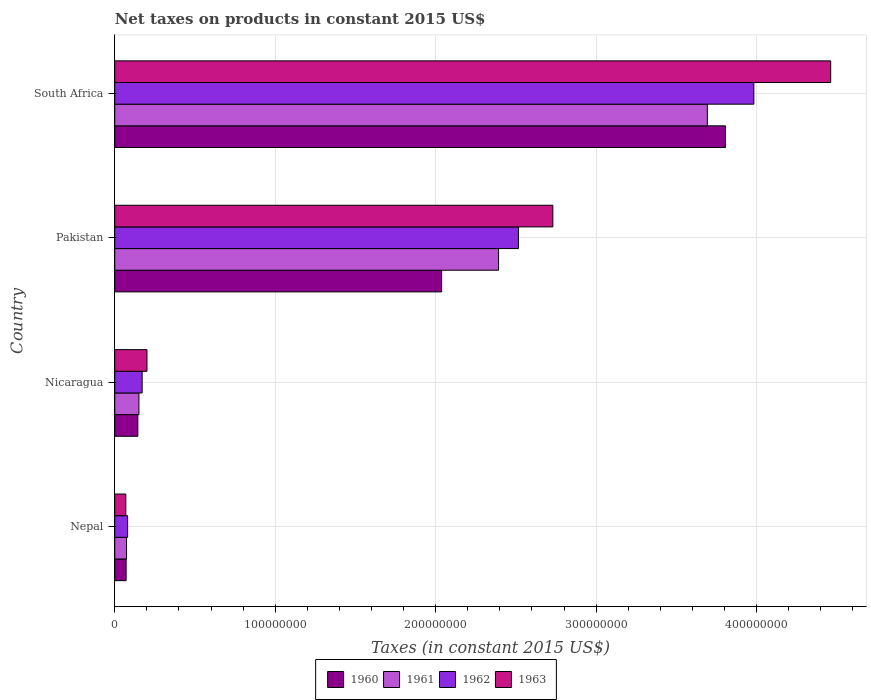How many groups of bars are there?
Offer a very short reply. 4. Are the number of bars per tick equal to the number of legend labels?
Provide a short and direct response. Yes. Are the number of bars on each tick of the Y-axis equal?
Your response must be concise. Yes. What is the label of the 4th group of bars from the top?
Your response must be concise. Nepal. In how many cases, is the number of bars for a given country not equal to the number of legend labels?
Your response must be concise. 0. What is the net taxes on products in 1963 in South Africa?
Provide a succinct answer. 4.46e+08. Across all countries, what is the maximum net taxes on products in 1961?
Ensure brevity in your answer.  3.69e+08. Across all countries, what is the minimum net taxes on products in 1963?
Make the answer very short. 6.89e+06. In which country was the net taxes on products in 1962 maximum?
Your answer should be compact. South Africa. In which country was the net taxes on products in 1961 minimum?
Offer a very short reply. Nepal. What is the total net taxes on products in 1963 in the graph?
Give a very brief answer. 7.46e+08. What is the difference between the net taxes on products in 1962 in Nepal and that in South Africa?
Provide a short and direct response. -3.90e+08. What is the difference between the net taxes on products in 1961 in Nicaragua and the net taxes on products in 1963 in Nepal?
Ensure brevity in your answer.  8.17e+06. What is the average net taxes on products in 1962 per country?
Ensure brevity in your answer.  1.69e+08. What is the difference between the net taxes on products in 1960 and net taxes on products in 1962 in Pakistan?
Give a very brief answer. -4.79e+07. In how many countries, is the net taxes on products in 1963 greater than 200000000 US$?
Offer a very short reply. 2. What is the ratio of the net taxes on products in 1961 in Nicaragua to that in Pakistan?
Ensure brevity in your answer.  0.06. What is the difference between the highest and the second highest net taxes on products in 1961?
Provide a short and direct response. 1.30e+08. What is the difference between the highest and the lowest net taxes on products in 1961?
Your answer should be compact. 3.62e+08. In how many countries, is the net taxes on products in 1960 greater than the average net taxes on products in 1960 taken over all countries?
Provide a succinct answer. 2. What does the 3rd bar from the bottom in Nicaragua represents?
Provide a short and direct response. 1962. Is it the case that in every country, the sum of the net taxes on products in 1963 and net taxes on products in 1962 is greater than the net taxes on products in 1960?
Make the answer very short. Yes. How many bars are there?
Provide a short and direct response. 16. Are all the bars in the graph horizontal?
Provide a short and direct response. Yes. Are the values on the major ticks of X-axis written in scientific E-notation?
Ensure brevity in your answer.  No. Does the graph contain grids?
Offer a very short reply. Yes. Where does the legend appear in the graph?
Your response must be concise. Bottom center. How many legend labels are there?
Give a very brief answer. 4. What is the title of the graph?
Provide a short and direct response. Net taxes on products in constant 2015 US$. Does "1999" appear as one of the legend labels in the graph?
Provide a short and direct response. No. What is the label or title of the X-axis?
Offer a terse response. Taxes (in constant 2015 US$). What is the Taxes (in constant 2015 US$) in 1960 in Nepal?
Your answer should be very brief. 7.09e+06. What is the Taxes (in constant 2015 US$) of 1961 in Nepal?
Ensure brevity in your answer.  7.35e+06. What is the Taxes (in constant 2015 US$) of 1962 in Nepal?
Keep it short and to the point. 8.01e+06. What is the Taxes (in constant 2015 US$) in 1963 in Nepal?
Provide a short and direct response. 6.89e+06. What is the Taxes (in constant 2015 US$) of 1960 in Nicaragua?
Keep it short and to the point. 1.44e+07. What is the Taxes (in constant 2015 US$) of 1961 in Nicaragua?
Give a very brief answer. 1.51e+07. What is the Taxes (in constant 2015 US$) of 1962 in Nicaragua?
Keep it short and to the point. 1.71e+07. What is the Taxes (in constant 2015 US$) of 1963 in Nicaragua?
Offer a terse response. 2.01e+07. What is the Taxes (in constant 2015 US$) of 1960 in Pakistan?
Provide a succinct answer. 2.04e+08. What is the Taxes (in constant 2015 US$) of 1961 in Pakistan?
Ensure brevity in your answer.  2.39e+08. What is the Taxes (in constant 2015 US$) in 1962 in Pakistan?
Your answer should be compact. 2.52e+08. What is the Taxes (in constant 2015 US$) of 1963 in Pakistan?
Keep it short and to the point. 2.73e+08. What is the Taxes (in constant 2015 US$) of 1960 in South Africa?
Make the answer very short. 3.81e+08. What is the Taxes (in constant 2015 US$) in 1961 in South Africa?
Provide a succinct answer. 3.69e+08. What is the Taxes (in constant 2015 US$) in 1962 in South Africa?
Ensure brevity in your answer.  3.98e+08. What is the Taxes (in constant 2015 US$) in 1963 in South Africa?
Your answer should be very brief. 4.46e+08. Across all countries, what is the maximum Taxes (in constant 2015 US$) of 1960?
Make the answer very short. 3.81e+08. Across all countries, what is the maximum Taxes (in constant 2015 US$) in 1961?
Give a very brief answer. 3.69e+08. Across all countries, what is the maximum Taxes (in constant 2015 US$) of 1962?
Your response must be concise. 3.98e+08. Across all countries, what is the maximum Taxes (in constant 2015 US$) in 1963?
Ensure brevity in your answer.  4.46e+08. Across all countries, what is the minimum Taxes (in constant 2015 US$) of 1960?
Ensure brevity in your answer.  7.09e+06. Across all countries, what is the minimum Taxes (in constant 2015 US$) in 1961?
Make the answer very short. 7.35e+06. Across all countries, what is the minimum Taxes (in constant 2015 US$) in 1962?
Offer a terse response. 8.01e+06. Across all countries, what is the minimum Taxes (in constant 2015 US$) in 1963?
Keep it short and to the point. 6.89e+06. What is the total Taxes (in constant 2015 US$) of 1960 in the graph?
Keep it short and to the point. 6.06e+08. What is the total Taxes (in constant 2015 US$) of 1961 in the graph?
Provide a succinct answer. 6.31e+08. What is the total Taxes (in constant 2015 US$) in 1962 in the graph?
Offer a very short reply. 6.75e+08. What is the total Taxes (in constant 2015 US$) of 1963 in the graph?
Give a very brief answer. 7.46e+08. What is the difference between the Taxes (in constant 2015 US$) in 1960 in Nepal and that in Nicaragua?
Ensure brevity in your answer.  -7.30e+06. What is the difference between the Taxes (in constant 2015 US$) in 1961 in Nepal and that in Nicaragua?
Keep it short and to the point. -7.71e+06. What is the difference between the Taxes (in constant 2015 US$) in 1962 in Nepal and that in Nicaragua?
Your response must be concise. -9.06e+06. What is the difference between the Taxes (in constant 2015 US$) in 1963 in Nepal and that in Nicaragua?
Make the answer very short. -1.32e+07. What is the difference between the Taxes (in constant 2015 US$) in 1960 in Nepal and that in Pakistan?
Your answer should be compact. -1.97e+08. What is the difference between the Taxes (in constant 2015 US$) in 1961 in Nepal and that in Pakistan?
Make the answer very short. -2.32e+08. What is the difference between the Taxes (in constant 2015 US$) of 1962 in Nepal and that in Pakistan?
Your answer should be very brief. -2.44e+08. What is the difference between the Taxes (in constant 2015 US$) in 1963 in Nepal and that in Pakistan?
Your answer should be very brief. -2.66e+08. What is the difference between the Taxes (in constant 2015 US$) in 1960 in Nepal and that in South Africa?
Give a very brief answer. -3.74e+08. What is the difference between the Taxes (in constant 2015 US$) of 1961 in Nepal and that in South Africa?
Make the answer very short. -3.62e+08. What is the difference between the Taxes (in constant 2015 US$) in 1962 in Nepal and that in South Africa?
Offer a terse response. -3.90e+08. What is the difference between the Taxes (in constant 2015 US$) of 1963 in Nepal and that in South Africa?
Provide a short and direct response. -4.39e+08. What is the difference between the Taxes (in constant 2015 US$) of 1960 in Nicaragua and that in Pakistan?
Make the answer very short. -1.89e+08. What is the difference between the Taxes (in constant 2015 US$) in 1961 in Nicaragua and that in Pakistan?
Provide a succinct answer. -2.24e+08. What is the difference between the Taxes (in constant 2015 US$) of 1962 in Nicaragua and that in Pakistan?
Your answer should be very brief. -2.35e+08. What is the difference between the Taxes (in constant 2015 US$) in 1963 in Nicaragua and that in Pakistan?
Your response must be concise. -2.53e+08. What is the difference between the Taxes (in constant 2015 US$) of 1960 in Nicaragua and that in South Africa?
Your answer should be compact. -3.66e+08. What is the difference between the Taxes (in constant 2015 US$) in 1961 in Nicaragua and that in South Africa?
Make the answer very short. -3.54e+08. What is the difference between the Taxes (in constant 2015 US$) of 1962 in Nicaragua and that in South Africa?
Your response must be concise. -3.81e+08. What is the difference between the Taxes (in constant 2015 US$) in 1963 in Nicaragua and that in South Africa?
Provide a short and direct response. -4.26e+08. What is the difference between the Taxes (in constant 2015 US$) of 1960 in Pakistan and that in South Africa?
Provide a short and direct response. -1.77e+08. What is the difference between the Taxes (in constant 2015 US$) of 1961 in Pakistan and that in South Africa?
Your answer should be very brief. -1.30e+08. What is the difference between the Taxes (in constant 2015 US$) in 1962 in Pakistan and that in South Africa?
Make the answer very short. -1.47e+08. What is the difference between the Taxes (in constant 2015 US$) of 1963 in Pakistan and that in South Africa?
Keep it short and to the point. -1.73e+08. What is the difference between the Taxes (in constant 2015 US$) of 1960 in Nepal and the Taxes (in constant 2015 US$) of 1961 in Nicaragua?
Offer a very short reply. -7.97e+06. What is the difference between the Taxes (in constant 2015 US$) in 1960 in Nepal and the Taxes (in constant 2015 US$) in 1962 in Nicaragua?
Ensure brevity in your answer.  -9.98e+06. What is the difference between the Taxes (in constant 2015 US$) in 1960 in Nepal and the Taxes (in constant 2015 US$) in 1963 in Nicaragua?
Provide a short and direct response. -1.30e+07. What is the difference between the Taxes (in constant 2015 US$) in 1961 in Nepal and the Taxes (in constant 2015 US$) in 1962 in Nicaragua?
Give a very brief answer. -9.71e+06. What is the difference between the Taxes (in constant 2015 US$) of 1961 in Nepal and the Taxes (in constant 2015 US$) of 1963 in Nicaragua?
Ensure brevity in your answer.  -1.27e+07. What is the difference between the Taxes (in constant 2015 US$) of 1962 in Nepal and the Taxes (in constant 2015 US$) of 1963 in Nicaragua?
Offer a very short reply. -1.21e+07. What is the difference between the Taxes (in constant 2015 US$) in 1960 in Nepal and the Taxes (in constant 2015 US$) in 1961 in Pakistan?
Offer a terse response. -2.32e+08. What is the difference between the Taxes (in constant 2015 US$) of 1960 in Nepal and the Taxes (in constant 2015 US$) of 1962 in Pakistan?
Provide a succinct answer. -2.44e+08. What is the difference between the Taxes (in constant 2015 US$) in 1960 in Nepal and the Taxes (in constant 2015 US$) in 1963 in Pakistan?
Offer a terse response. -2.66e+08. What is the difference between the Taxes (in constant 2015 US$) in 1961 in Nepal and the Taxes (in constant 2015 US$) in 1962 in Pakistan?
Keep it short and to the point. -2.44e+08. What is the difference between the Taxes (in constant 2015 US$) of 1961 in Nepal and the Taxes (in constant 2015 US$) of 1963 in Pakistan?
Provide a short and direct response. -2.66e+08. What is the difference between the Taxes (in constant 2015 US$) of 1962 in Nepal and the Taxes (in constant 2015 US$) of 1963 in Pakistan?
Keep it short and to the point. -2.65e+08. What is the difference between the Taxes (in constant 2015 US$) in 1960 in Nepal and the Taxes (in constant 2015 US$) in 1961 in South Africa?
Give a very brief answer. -3.62e+08. What is the difference between the Taxes (in constant 2015 US$) of 1960 in Nepal and the Taxes (in constant 2015 US$) of 1962 in South Africa?
Offer a very short reply. -3.91e+08. What is the difference between the Taxes (in constant 2015 US$) in 1960 in Nepal and the Taxes (in constant 2015 US$) in 1963 in South Africa?
Your response must be concise. -4.39e+08. What is the difference between the Taxes (in constant 2015 US$) of 1961 in Nepal and the Taxes (in constant 2015 US$) of 1962 in South Africa?
Provide a succinct answer. -3.91e+08. What is the difference between the Taxes (in constant 2015 US$) of 1961 in Nepal and the Taxes (in constant 2015 US$) of 1963 in South Africa?
Offer a terse response. -4.39e+08. What is the difference between the Taxes (in constant 2015 US$) in 1962 in Nepal and the Taxes (in constant 2015 US$) in 1963 in South Africa?
Your answer should be very brief. -4.38e+08. What is the difference between the Taxes (in constant 2015 US$) in 1960 in Nicaragua and the Taxes (in constant 2015 US$) in 1961 in Pakistan?
Offer a terse response. -2.25e+08. What is the difference between the Taxes (in constant 2015 US$) in 1960 in Nicaragua and the Taxes (in constant 2015 US$) in 1962 in Pakistan?
Your answer should be very brief. -2.37e+08. What is the difference between the Taxes (in constant 2015 US$) in 1960 in Nicaragua and the Taxes (in constant 2015 US$) in 1963 in Pakistan?
Offer a terse response. -2.59e+08. What is the difference between the Taxes (in constant 2015 US$) of 1961 in Nicaragua and the Taxes (in constant 2015 US$) of 1962 in Pakistan?
Make the answer very short. -2.37e+08. What is the difference between the Taxes (in constant 2015 US$) of 1961 in Nicaragua and the Taxes (in constant 2015 US$) of 1963 in Pakistan?
Keep it short and to the point. -2.58e+08. What is the difference between the Taxes (in constant 2015 US$) in 1962 in Nicaragua and the Taxes (in constant 2015 US$) in 1963 in Pakistan?
Your answer should be compact. -2.56e+08. What is the difference between the Taxes (in constant 2015 US$) in 1960 in Nicaragua and the Taxes (in constant 2015 US$) in 1961 in South Africa?
Provide a succinct answer. -3.55e+08. What is the difference between the Taxes (in constant 2015 US$) of 1960 in Nicaragua and the Taxes (in constant 2015 US$) of 1962 in South Africa?
Keep it short and to the point. -3.84e+08. What is the difference between the Taxes (in constant 2015 US$) in 1960 in Nicaragua and the Taxes (in constant 2015 US$) in 1963 in South Africa?
Offer a terse response. -4.32e+08. What is the difference between the Taxes (in constant 2015 US$) of 1961 in Nicaragua and the Taxes (in constant 2015 US$) of 1962 in South Africa?
Offer a terse response. -3.83e+08. What is the difference between the Taxes (in constant 2015 US$) of 1961 in Nicaragua and the Taxes (in constant 2015 US$) of 1963 in South Africa?
Your answer should be compact. -4.31e+08. What is the difference between the Taxes (in constant 2015 US$) in 1962 in Nicaragua and the Taxes (in constant 2015 US$) in 1963 in South Africa?
Offer a very short reply. -4.29e+08. What is the difference between the Taxes (in constant 2015 US$) in 1960 in Pakistan and the Taxes (in constant 2015 US$) in 1961 in South Africa?
Offer a terse response. -1.66e+08. What is the difference between the Taxes (in constant 2015 US$) of 1960 in Pakistan and the Taxes (in constant 2015 US$) of 1962 in South Africa?
Provide a succinct answer. -1.95e+08. What is the difference between the Taxes (in constant 2015 US$) of 1960 in Pakistan and the Taxes (in constant 2015 US$) of 1963 in South Africa?
Your answer should be very brief. -2.42e+08. What is the difference between the Taxes (in constant 2015 US$) of 1961 in Pakistan and the Taxes (in constant 2015 US$) of 1962 in South Africa?
Make the answer very short. -1.59e+08. What is the difference between the Taxes (in constant 2015 US$) in 1961 in Pakistan and the Taxes (in constant 2015 US$) in 1963 in South Africa?
Offer a terse response. -2.07e+08. What is the difference between the Taxes (in constant 2015 US$) of 1962 in Pakistan and the Taxes (in constant 2015 US$) of 1963 in South Africa?
Make the answer very short. -1.95e+08. What is the average Taxes (in constant 2015 US$) in 1960 per country?
Keep it short and to the point. 1.51e+08. What is the average Taxes (in constant 2015 US$) of 1961 per country?
Provide a succinct answer. 1.58e+08. What is the average Taxes (in constant 2015 US$) in 1962 per country?
Offer a very short reply. 1.69e+08. What is the average Taxes (in constant 2015 US$) of 1963 per country?
Your response must be concise. 1.87e+08. What is the difference between the Taxes (in constant 2015 US$) of 1960 and Taxes (in constant 2015 US$) of 1961 in Nepal?
Keep it short and to the point. -2.63e+05. What is the difference between the Taxes (in constant 2015 US$) of 1960 and Taxes (in constant 2015 US$) of 1962 in Nepal?
Offer a very short reply. -9.19e+05. What is the difference between the Taxes (in constant 2015 US$) in 1960 and Taxes (in constant 2015 US$) in 1963 in Nepal?
Give a very brief answer. 1.97e+05. What is the difference between the Taxes (in constant 2015 US$) of 1961 and Taxes (in constant 2015 US$) of 1962 in Nepal?
Provide a short and direct response. -6.56e+05. What is the difference between the Taxes (in constant 2015 US$) in 1961 and Taxes (in constant 2015 US$) in 1963 in Nepal?
Provide a short and direct response. 4.60e+05. What is the difference between the Taxes (in constant 2015 US$) of 1962 and Taxes (in constant 2015 US$) of 1963 in Nepal?
Your answer should be very brief. 1.12e+06. What is the difference between the Taxes (in constant 2015 US$) of 1960 and Taxes (in constant 2015 US$) of 1961 in Nicaragua?
Provide a short and direct response. -6.69e+05. What is the difference between the Taxes (in constant 2015 US$) of 1960 and Taxes (in constant 2015 US$) of 1962 in Nicaragua?
Give a very brief answer. -2.68e+06. What is the difference between the Taxes (in constant 2015 US$) of 1960 and Taxes (in constant 2015 US$) of 1963 in Nicaragua?
Offer a terse response. -5.69e+06. What is the difference between the Taxes (in constant 2015 US$) of 1961 and Taxes (in constant 2015 US$) of 1962 in Nicaragua?
Make the answer very short. -2.01e+06. What is the difference between the Taxes (in constant 2015 US$) of 1961 and Taxes (in constant 2015 US$) of 1963 in Nicaragua?
Ensure brevity in your answer.  -5.02e+06. What is the difference between the Taxes (in constant 2015 US$) in 1962 and Taxes (in constant 2015 US$) in 1963 in Nicaragua?
Give a very brief answer. -3.01e+06. What is the difference between the Taxes (in constant 2015 US$) of 1960 and Taxes (in constant 2015 US$) of 1961 in Pakistan?
Give a very brief answer. -3.55e+07. What is the difference between the Taxes (in constant 2015 US$) in 1960 and Taxes (in constant 2015 US$) in 1962 in Pakistan?
Provide a succinct answer. -4.79e+07. What is the difference between the Taxes (in constant 2015 US$) in 1960 and Taxes (in constant 2015 US$) in 1963 in Pakistan?
Provide a short and direct response. -6.93e+07. What is the difference between the Taxes (in constant 2015 US$) in 1961 and Taxes (in constant 2015 US$) in 1962 in Pakistan?
Give a very brief answer. -1.24e+07. What is the difference between the Taxes (in constant 2015 US$) in 1961 and Taxes (in constant 2015 US$) in 1963 in Pakistan?
Provide a succinct answer. -3.38e+07. What is the difference between the Taxes (in constant 2015 US$) of 1962 and Taxes (in constant 2015 US$) of 1963 in Pakistan?
Offer a terse response. -2.14e+07. What is the difference between the Taxes (in constant 2015 US$) in 1960 and Taxes (in constant 2015 US$) in 1961 in South Africa?
Make the answer very short. 1.13e+07. What is the difference between the Taxes (in constant 2015 US$) of 1960 and Taxes (in constant 2015 US$) of 1962 in South Africa?
Provide a short and direct response. -1.76e+07. What is the difference between the Taxes (in constant 2015 US$) in 1960 and Taxes (in constant 2015 US$) in 1963 in South Africa?
Your answer should be very brief. -6.55e+07. What is the difference between the Taxes (in constant 2015 US$) in 1961 and Taxes (in constant 2015 US$) in 1962 in South Africa?
Your response must be concise. -2.90e+07. What is the difference between the Taxes (in constant 2015 US$) in 1961 and Taxes (in constant 2015 US$) in 1963 in South Africa?
Your answer should be compact. -7.69e+07. What is the difference between the Taxes (in constant 2015 US$) in 1962 and Taxes (in constant 2015 US$) in 1963 in South Africa?
Provide a short and direct response. -4.79e+07. What is the ratio of the Taxes (in constant 2015 US$) of 1960 in Nepal to that in Nicaragua?
Your answer should be very brief. 0.49. What is the ratio of the Taxes (in constant 2015 US$) of 1961 in Nepal to that in Nicaragua?
Make the answer very short. 0.49. What is the ratio of the Taxes (in constant 2015 US$) of 1962 in Nepal to that in Nicaragua?
Give a very brief answer. 0.47. What is the ratio of the Taxes (in constant 2015 US$) of 1963 in Nepal to that in Nicaragua?
Offer a terse response. 0.34. What is the ratio of the Taxes (in constant 2015 US$) in 1960 in Nepal to that in Pakistan?
Keep it short and to the point. 0.03. What is the ratio of the Taxes (in constant 2015 US$) of 1961 in Nepal to that in Pakistan?
Give a very brief answer. 0.03. What is the ratio of the Taxes (in constant 2015 US$) in 1962 in Nepal to that in Pakistan?
Your response must be concise. 0.03. What is the ratio of the Taxes (in constant 2015 US$) of 1963 in Nepal to that in Pakistan?
Provide a short and direct response. 0.03. What is the ratio of the Taxes (in constant 2015 US$) in 1960 in Nepal to that in South Africa?
Provide a short and direct response. 0.02. What is the ratio of the Taxes (in constant 2015 US$) of 1961 in Nepal to that in South Africa?
Ensure brevity in your answer.  0.02. What is the ratio of the Taxes (in constant 2015 US$) of 1962 in Nepal to that in South Africa?
Offer a terse response. 0.02. What is the ratio of the Taxes (in constant 2015 US$) of 1963 in Nepal to that in South Africa?
Provide a short and direct response. 0.02. What is the ratio of the Taxes (in constant 2015 US$) in 1960 in Nicaragua to that in Pakistan?
Make the answer very short. 0.07. What is the ratio of the Taxes (in constant 2015 US$) of 1961 in Nicaragua to that in Pakistan?
Your answer should be very brief. 0.06. What is the ratio of the Taxes (in constant 2015 US$) of 1962 in Nicaragua to that in Pakistan?
Your answer should be compact. 0.07. What is the ratio of the Taxes (in constant 2015 US$) of 1963 in Nicaragua to that in Pakistan?
Your answer should be very brief. 0.07. What is the ratio of the Taxes (in constant 2015 US$) of 1960 in Nicaragua to that in South Africa?
Offer a terse response. 0.04. What is the ratio of the Taxes (in constant 2015 US$) in 1961 in Nicaragua to that in South Africa?
Provide a succinct answer. 0.04. What is the ratio of the Taxes (in constant 2015 US$) in 1962 in Nicaragua to that in South Africa?
Keep it short and to the point. 0.04. What is the ratio of the Taxes (in constant 2015 US$) of 1963 in Nicaragua to that in South Africa?
Offer a terse response. 0.04. What is the ratio of the Taxes (in constant 2015 US$) of 1960 in Pakistan to that in South Africa?
Provide a succinct answer. 0.54. What is the ratio of the Taxes (in constant 2015 US$) in 1961 in Pakistan to that in South Africa?
Offer a very short reply. 0.65. What is the ratio of the Taxes (in constant 2015 US$) of 1962 in Pakistan to that in South Africa?
Make the answer very short. 0.63. What is the ratio of the Taxes (in constant 2015 US$) of 1963 in Pakistan to that in South Africa?
Your answer should be compact. 0.61. What is the difference between the highest and the second highest Taxes (in constant 2015 US$) in 1960?
Give a very brief answer. 1.77e+08. What is the difference between the highest and the second highest Taxes (in constant 2015 US$) in 1961?
Offer a very short reply. 1.30e+08. What is the difference between the highest and the second highest Taxes (in constant 2015 US$) in 1962?
Offer a terse response. 1.47e+08. What is the difference between the highest and the second highest Taxes (in constant 2015 US$) in 1963?
Provide a short and direct response. 1.73e+08. What is the difference between the highest and the lowest Taxes (in constant 2015 US$) of 1960?
Ensure brevity in your answer.  3.74e+08. What is the difference between the highest and the lowest Taxes (in constant 2015 US$) of 1961?
Offer a very short reply. 3.62e+08. What is the difference between the highest and the lowest Taxes (in constant 2015 US$) in 1962?
Offer a terse response. 3.90e+08. What is the difference between the highest and the lowest Taxes (in constant 2015 US$) of 1963?
Keep it short and to the point. 4.39e+08. 